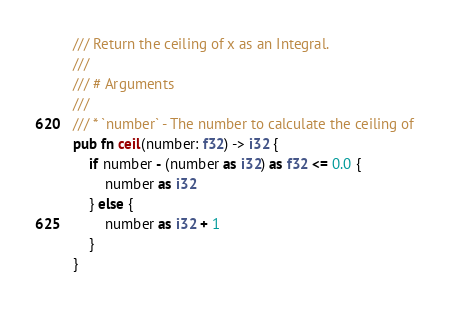Convert code to text. <code><loc_0><loc_0><loc_500><loc_500><_Rust_>/// Return the ceiling of x as an Integral.
///
/// # Arguments
///
/// * `number` - The number to calculate the ceiling of
pub fn ceil(number: f32) -> i32 {
    if number - (number as i32) as f32 <= 0.0 {
        number as i32
    } else {
        number as i32 + 1
    }
}
</code> 